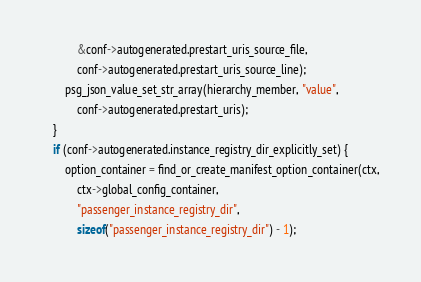Convert code to text. <code><loc_0><loc_0><loc_500><loc_500><_C_>            &conf->autogenerated.prestart_uris_source_file,
            conf->autogenerated.prestart_uris_source_line);
        psg_json_value_set_str_array(hierarchy_member, "value",
            conf->autogenerated.prestart_uris);
    }
    if (conf->autogenerated.instance_registry_dir_explicitly_set) {
        option_container = find_or_create_manifest_option_container(ctx,
            ctx->global_config_container,
            "passenger_instance_registry_dir",
            sizeof("passenger_instance_registry_dir") - 1);</code> 